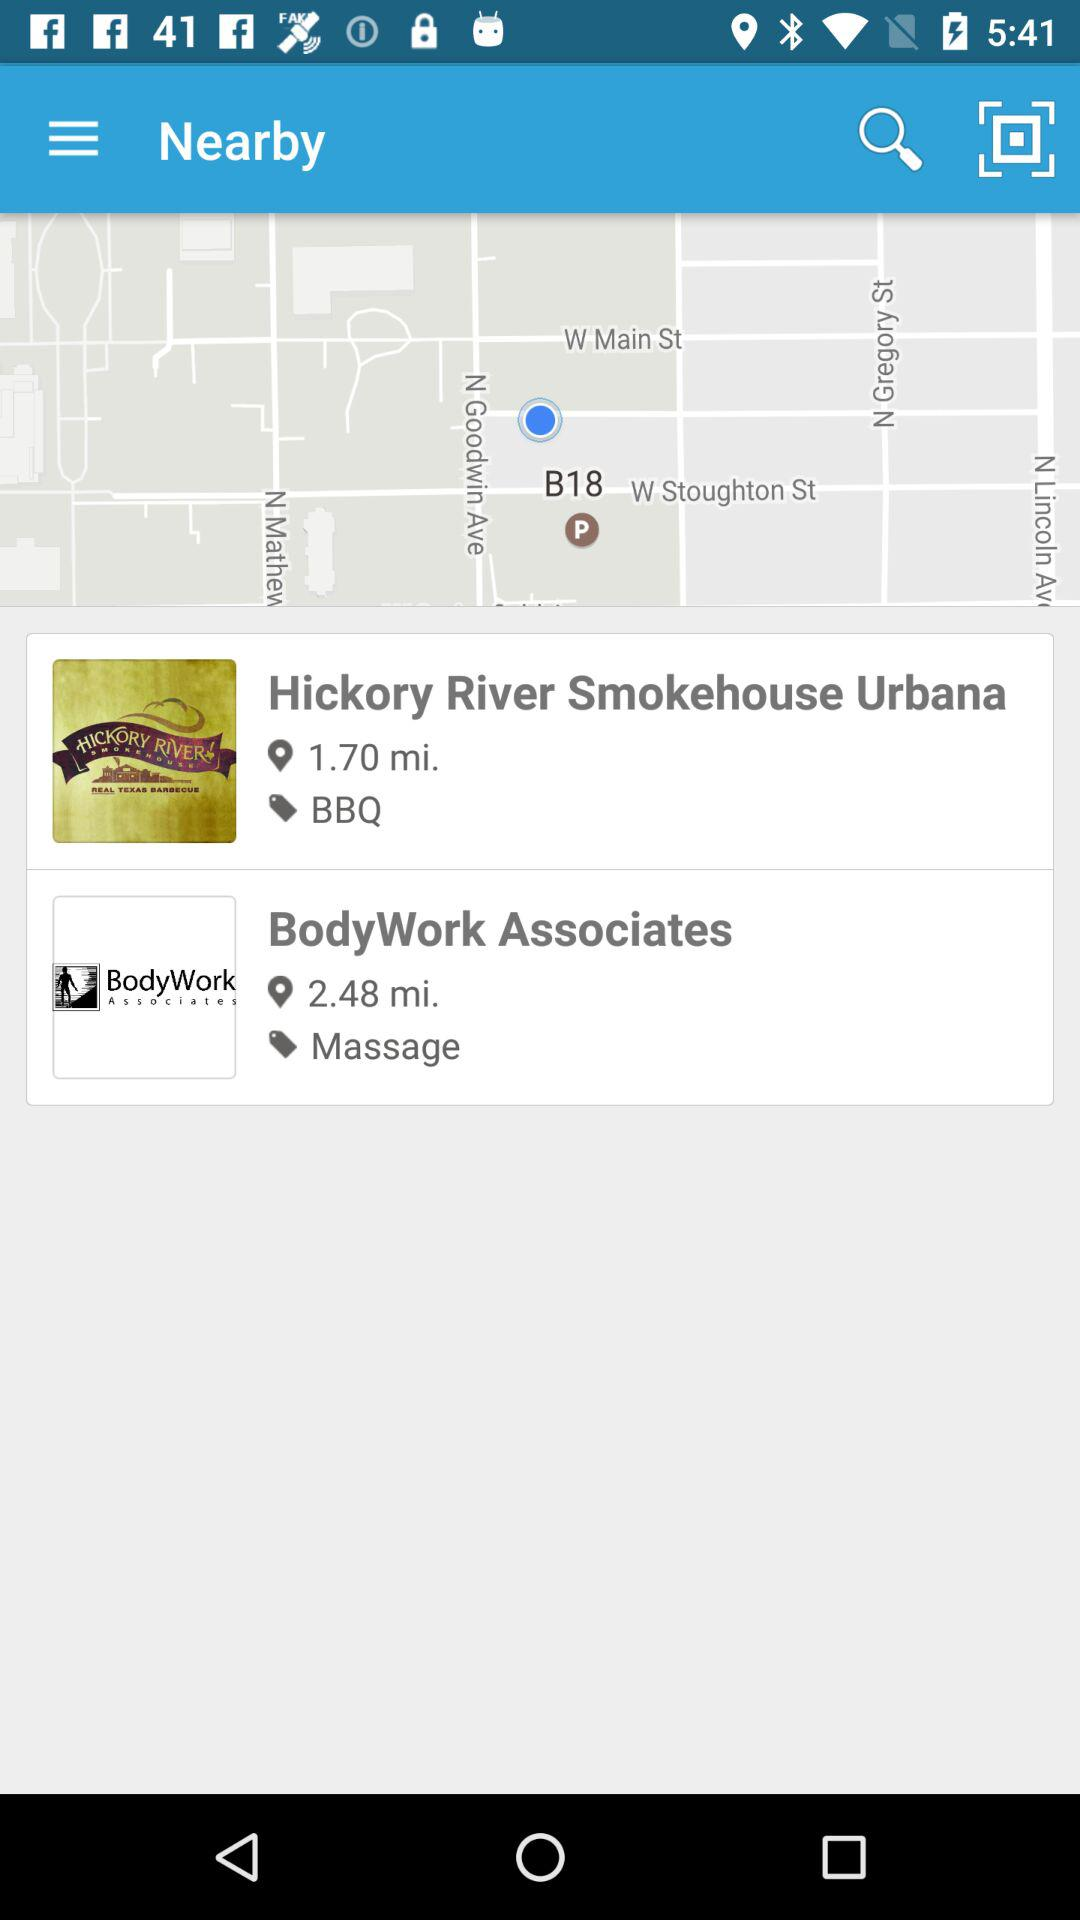How far is "Hickory River Smokehouse Urbana"? The "Hickory River Smokehouse Urbana" is 1.70 miles away. 